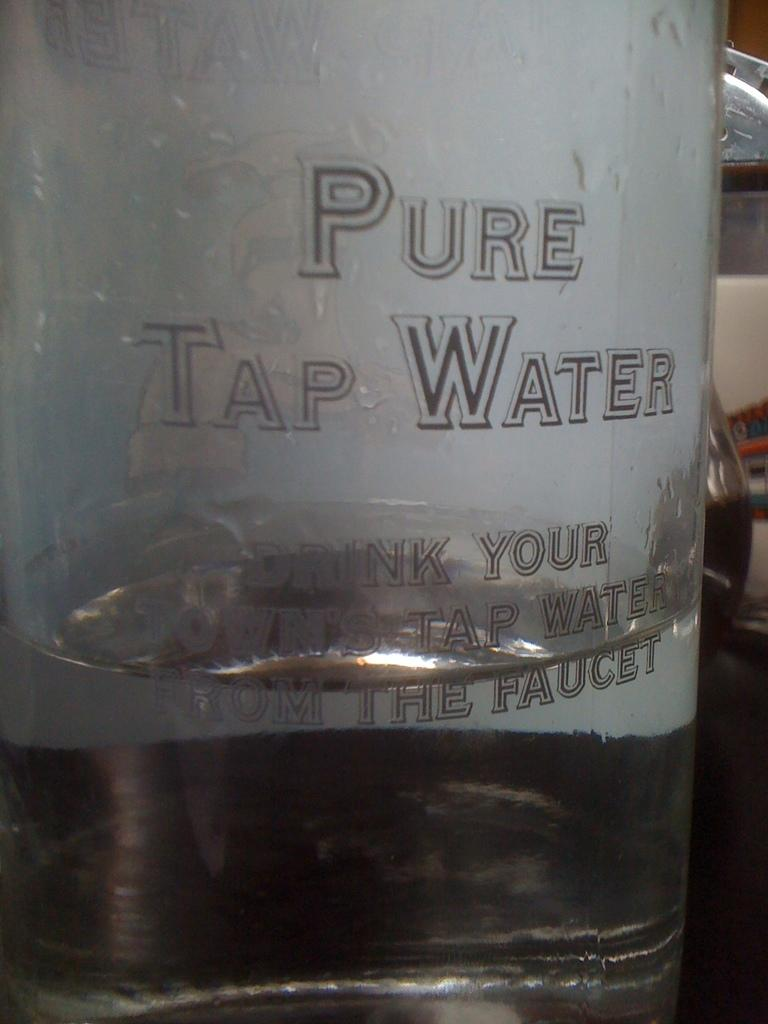<image>
Summarize the visual content of the image. A large containter of Pure Tap Water is sitting on a table. 